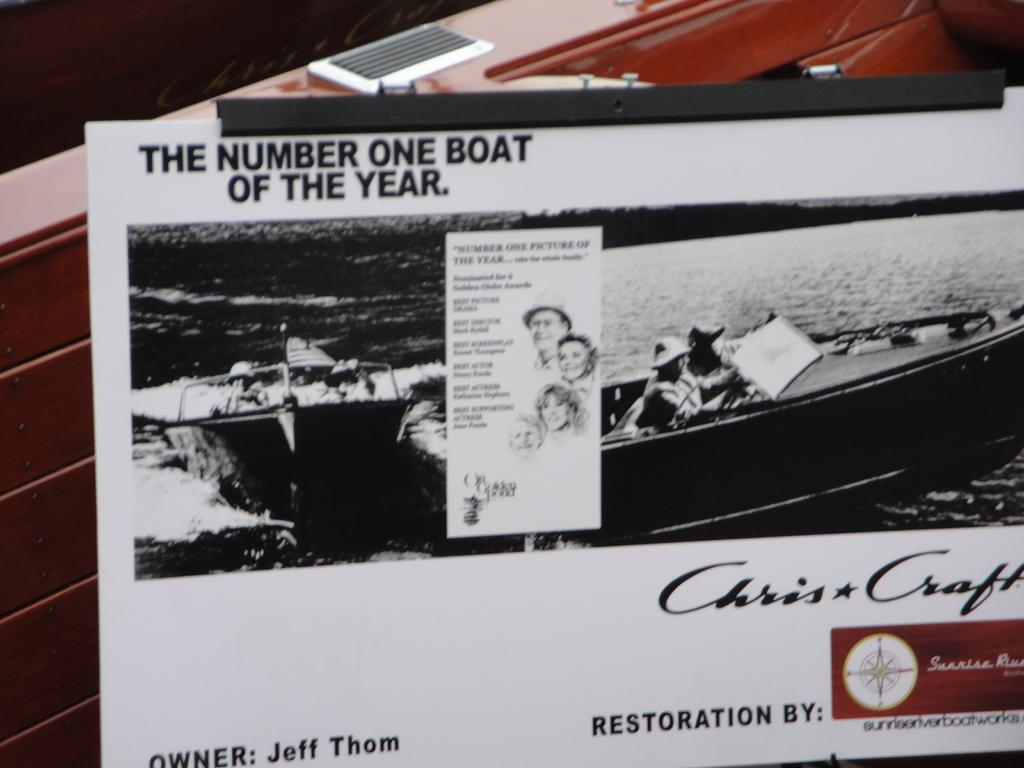What is the main subject of the poster in the image? The poster contains pictures of people, boats, and water. What type of writing is on the poster? There is writing on the poster. What color is the background of the poster? The background of the poster is red. What other element is present on the poster? The poster contains a logo. What type of rice is being served in the image? There is no rice present in the image; it features a poster with various elements. How many pairs of jeans are visible in the image? There are no jeans present in the image; it features a poster with various elements. 